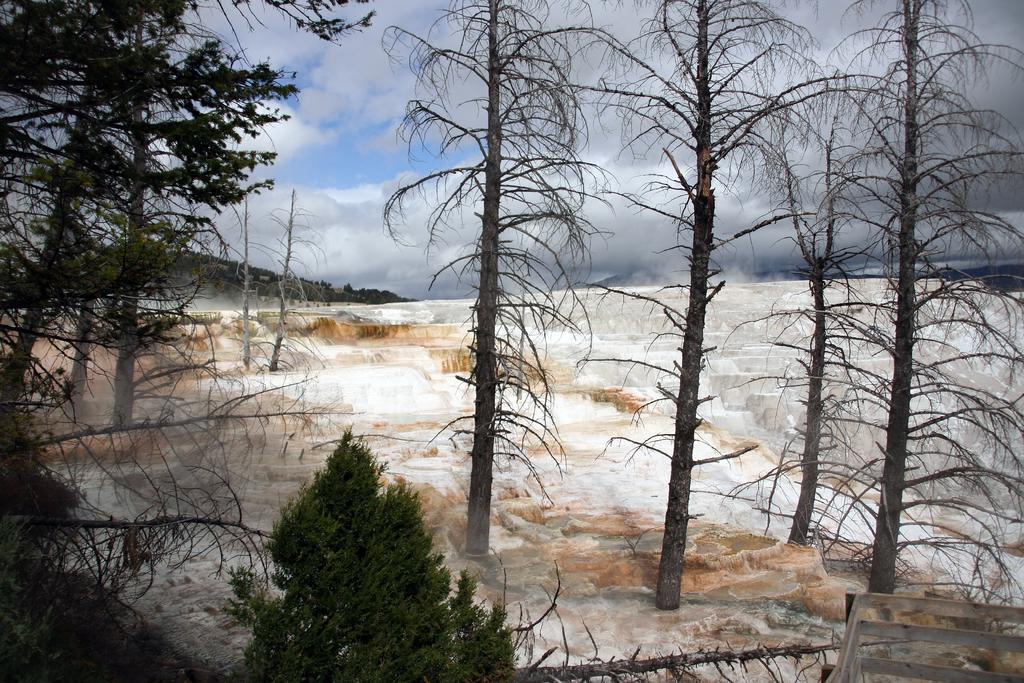What is the condition of the land in the image? The land in the image is covered with snow. What type of vegetation can be seen in the image? There are trees in the image. What is visible in the background of the image? There is a mountain and the sky visible in the background of the image. What type of quill is being used to write on the veil in the image? There is no quill or veil present in the image; it features snow-covered land, trees, a mountain, and the sky. 